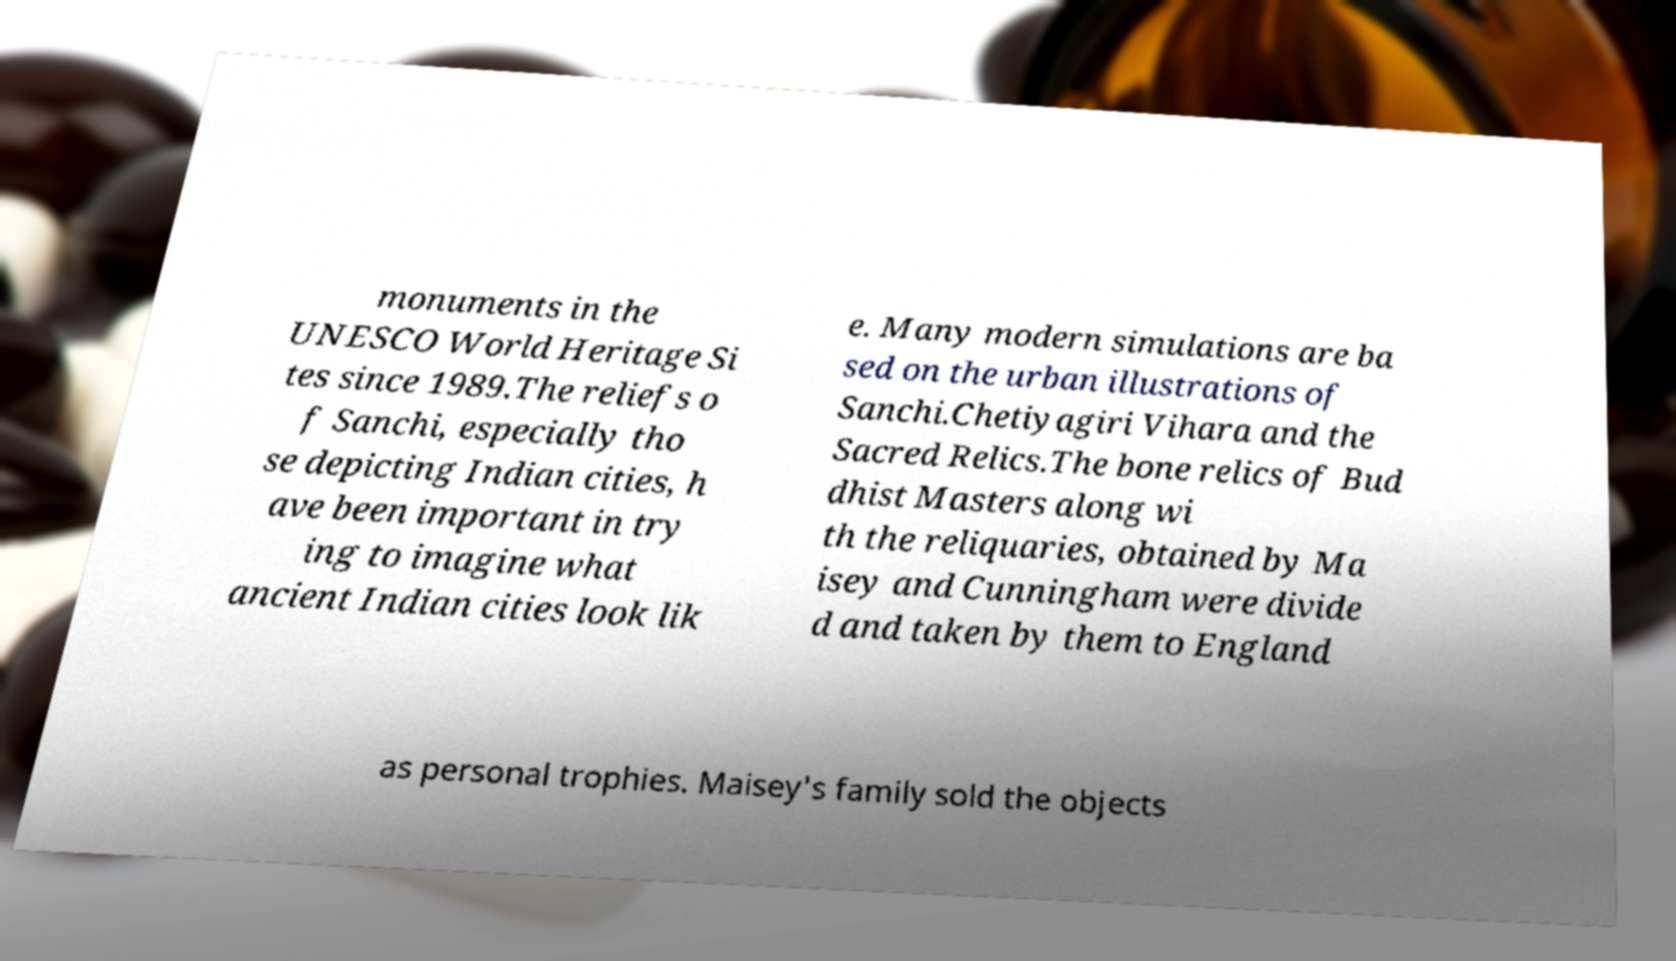For documentation purposes, I need the text within this image transcribed. Could you provide that? monuments in the UNESCO World Heritage Si tes since 1989.The reliefs o f Sanchi, especially tho se depicting Indian cities, h ave been important in try ing to imagine what ancient Indian cities look lik e. Many modern simulations are ba sed on the urban illustrations of Sanchi.Chetiyagiri Vihara and the Sacred Relics.The bone relics of Bud dhist Masters along wi th the reliquaries, obtained by Ma isey and Cunningham were divide d and taken by them to England as personal trophies. Maisey's family sold the objects 